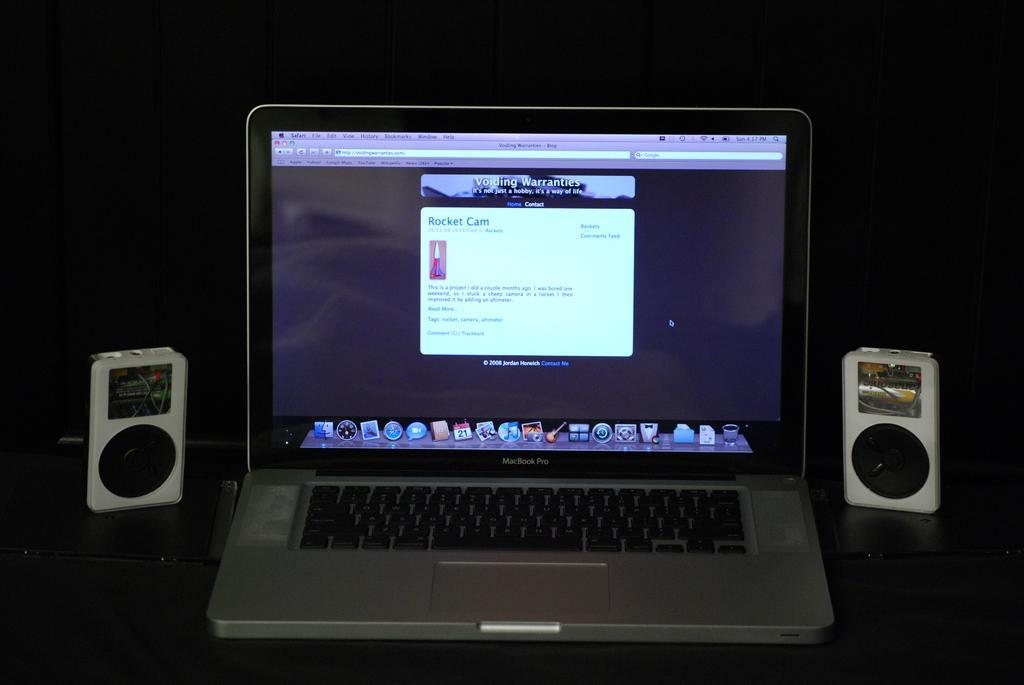How would you summarize this image in a sentence or two? In this image we can see a laptop, speakers beside the laptop and a dark background. 